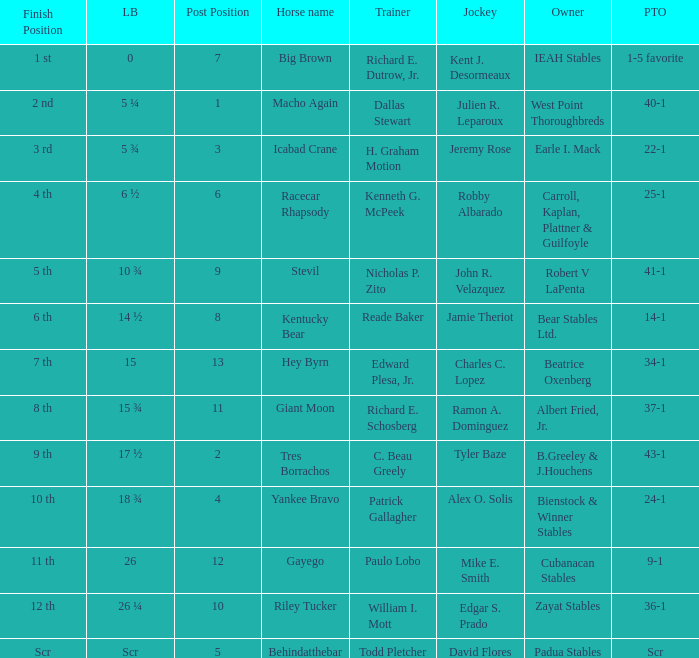Who was the jockey with post time odds set at 34-1? Charles C. Lopez. 